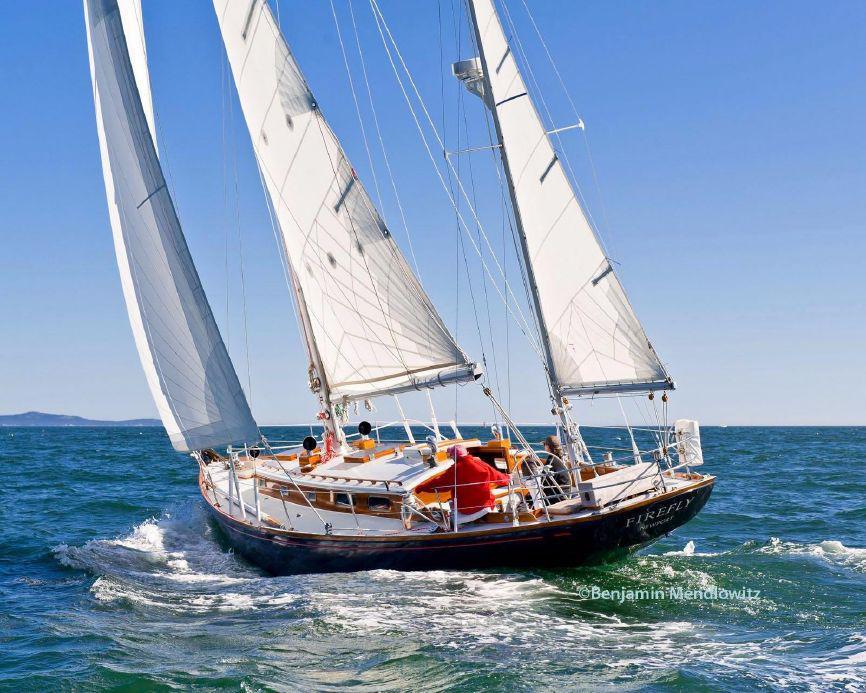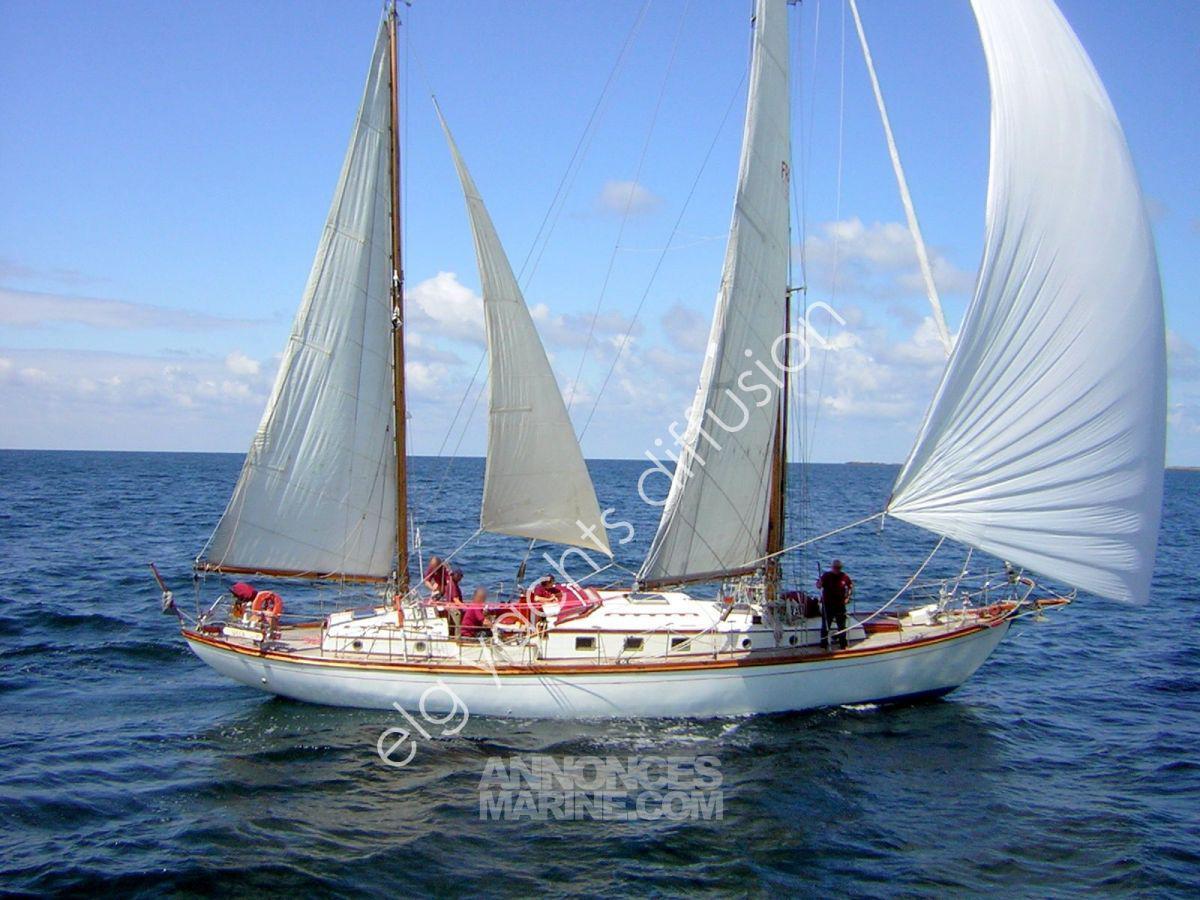The first image is the image on the left, the second image is the image on the right. For the images displayed, is the sentence "The boat in the right image has exactly four sails." factually correct? Answer yes or no. Yes. The first image is the image on the left, the second image is the image on the right. Examine the images to the left and right. Is the description "The left and right image contains a total of seven open sails." accurate? Answer yes or no. Yes. 